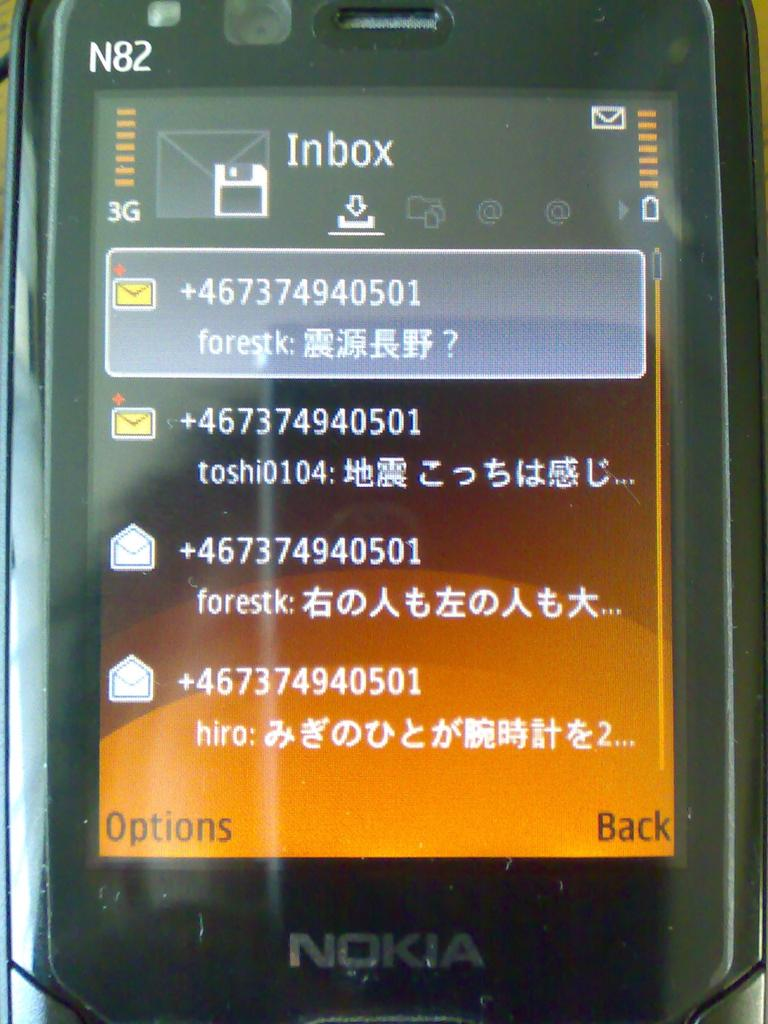Provide a one-sentence caption for the provided image. A NOKIA phone showing four Inbox mail messages. 